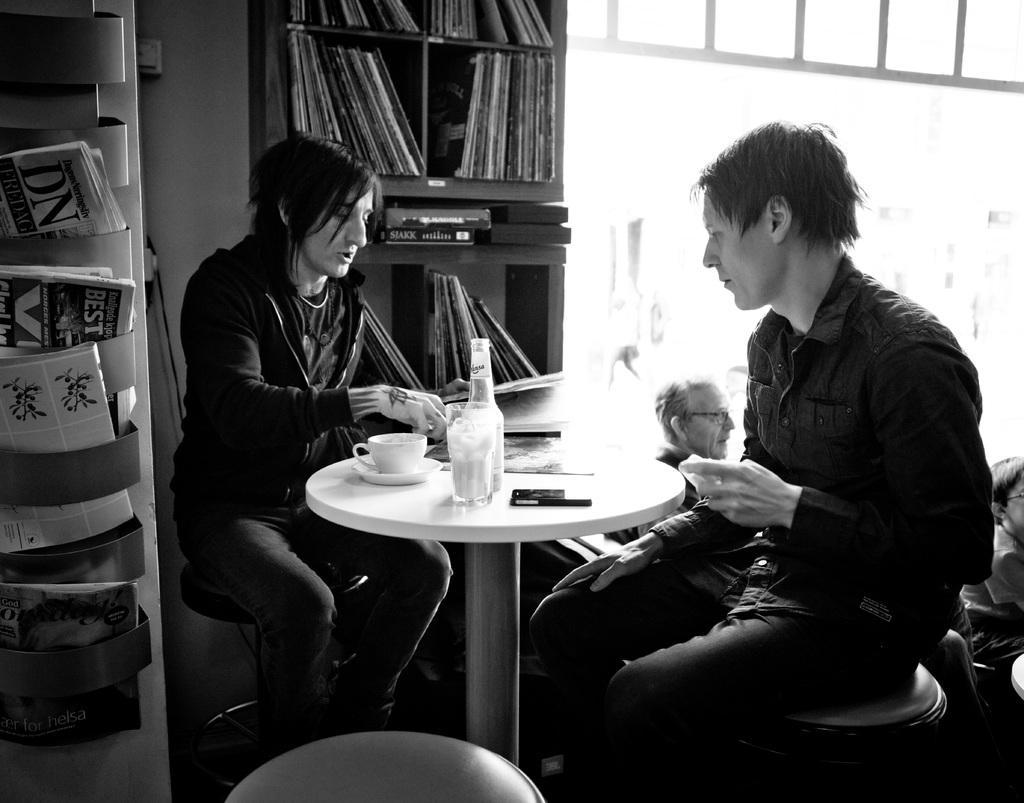Can you describe this image briefly? Two persons are sitting on stools. There is a table. On the table there is a bottle cup and saucer pen and a book. Behind this person there is a cupboard. There are book son this cupboard. There are some racks. And some magazines are kept over here. Some people are sitting behind this people. 